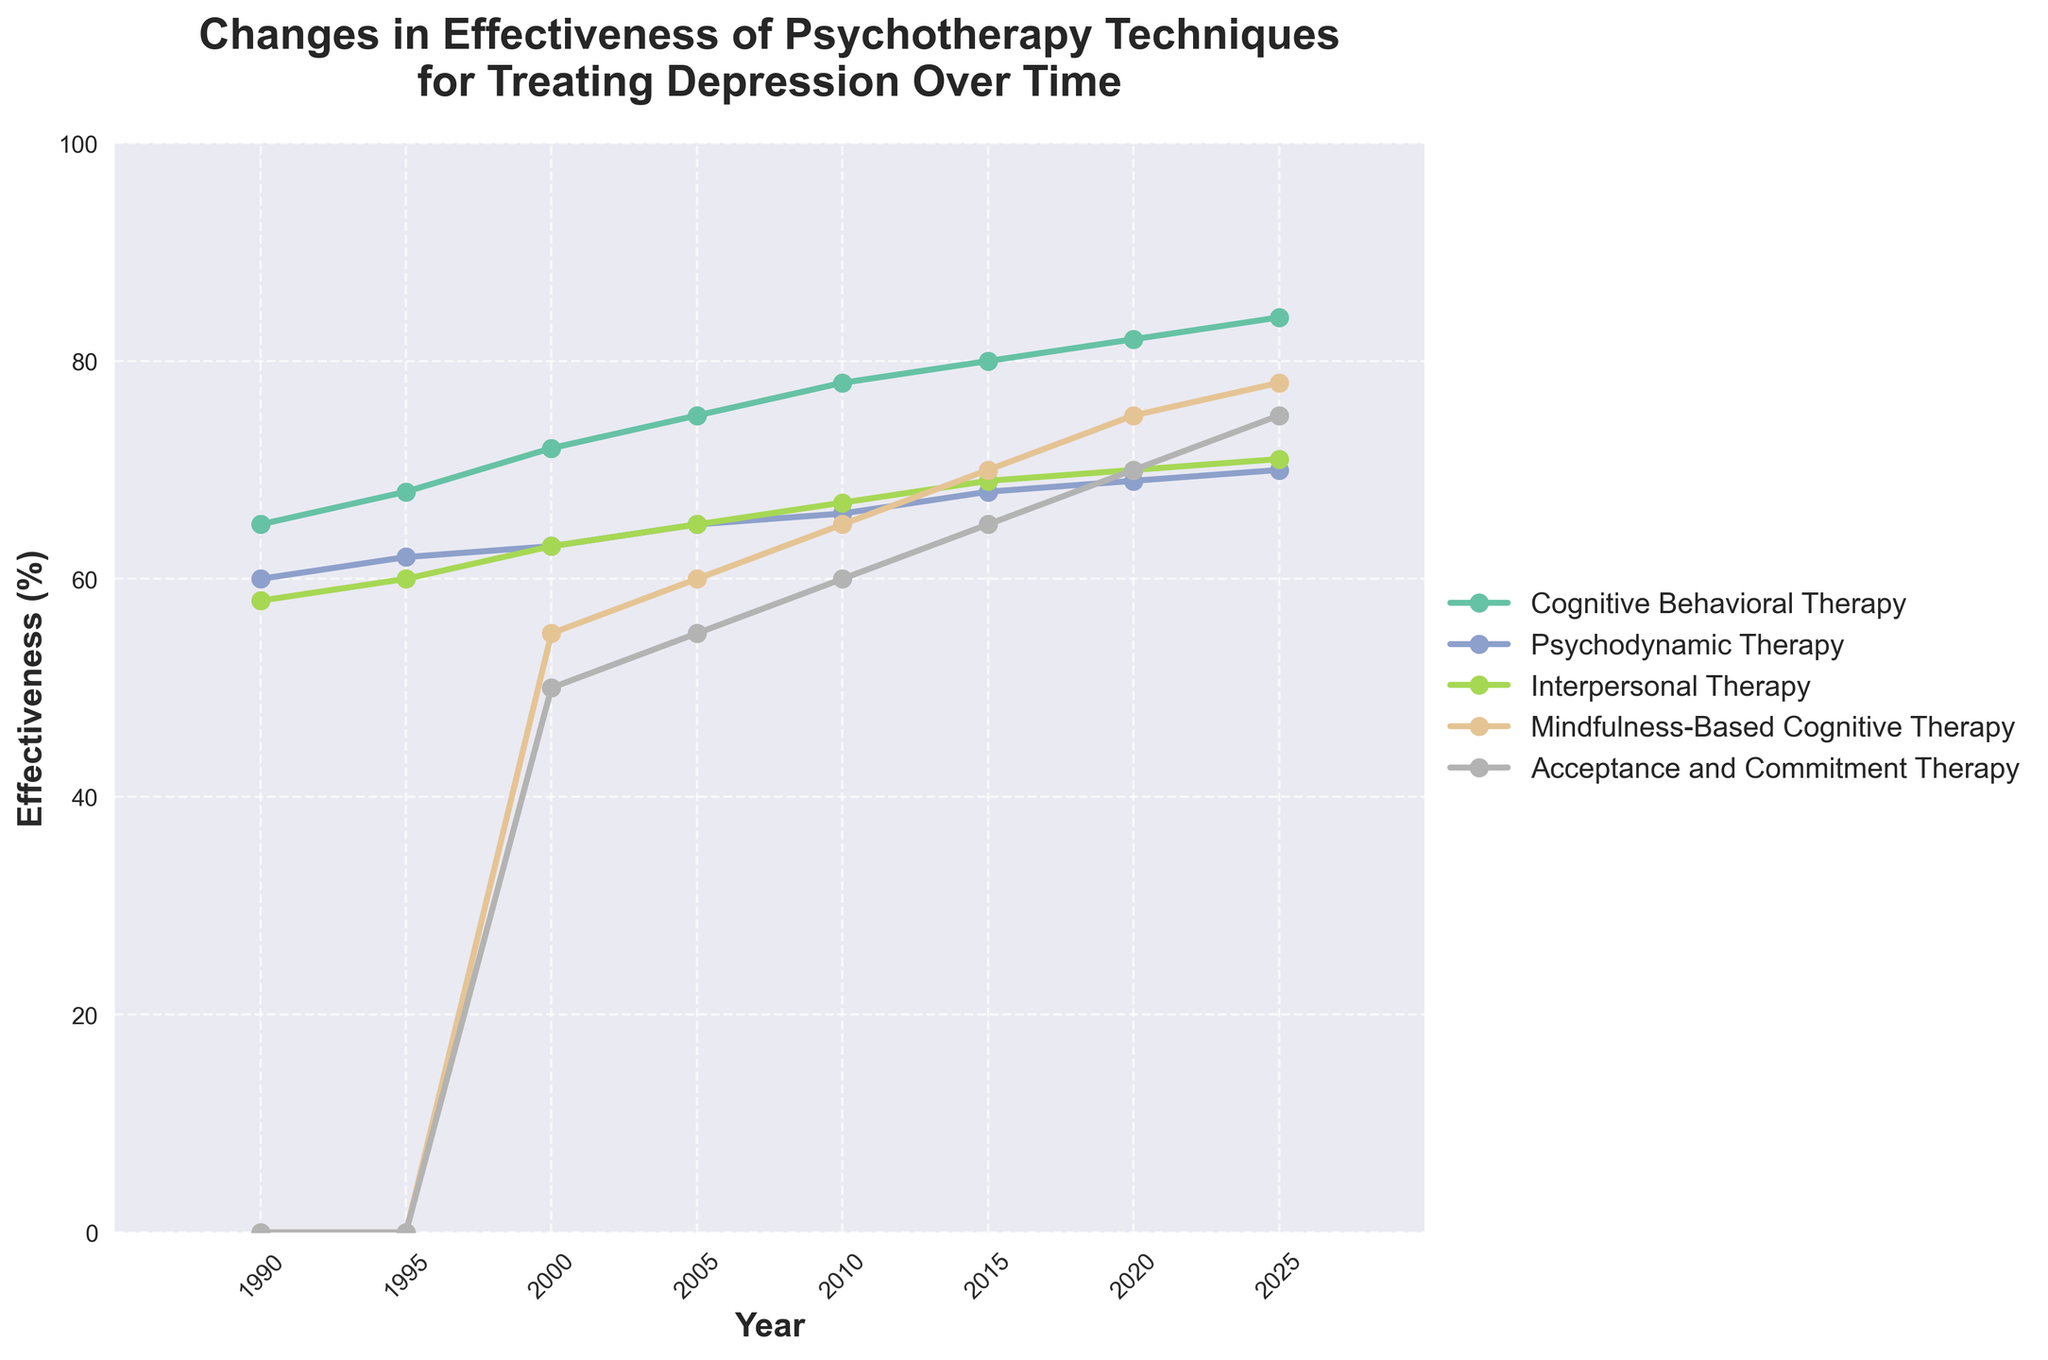What is the trend of Cognitive Behavioral Therapy's effectiveness from 1990 to 2025? To answer this, observe the line representing Cognitive Behavioral Therapy (CBT) on the plot. The line shows a consistent upward trend from 65% in 1990 to 84% in 2025.
Answer: Increasing Which psychotherapy technique had the largest increase in effectiveness between 2000 and 2010? Look at the changes between 2000 and 2010 for each technique. CBT increased by 6% (72% to 78%), Psychodynamic Therapy by 3% (63% to 66%), Interpersonal Therapy by 4% (63% to 67%), Mindfulness-Based Cognitive Therapy by 10% (55% to 65%), and Acceptance and Commitment Therapy by 10% (50% to 60%). Both Mindfulness-Based Cognitive Therapy and Acceptance and Commitment Therapy had the largest increase of 10%.
Answer: Mindfulness-Based Cognitive Therapy and Acceptance and Commitment Therapy Which technique shows the highest effectiveness in 2020? Locate the year 2020 on the x-axis and check the highest value among all techniques. CBT shows the highest effectiveness of 82%.
Answer: Cognitive Behavioral Therapy In which year did Mindfulness-Based Cognitive Therapy achieve a higher effectiveness than Psychodynamic Therapy? Compare the effectiveness of both techniques over time. In 2015, Mindfulness-Based Cognitive Therapy reached 70%, while Psychodynamic Therapy stood at 68%.
Answer: 2015 What is the average effectiveness of Interpersonal Therapy over the years presented in the chart? Sum the effectiveness values for Interpersonal Therapy from 1990 to 2025 and divide by the number of years: (58 + 60 + 63 + 65 + 67 + 69 + 70 + 71)/8 = 523/8 = 65.375.
Answer: 65.375 Between 1990 and 2025, which year displayed the smallest gap in effectiveness between CBT and Psychodynamic Therapy? Compute the differences for each year: 
- 1990: 65 - 60 = 5
- 1995: 68 - 62 = 6
- 2000: 72 - 63 = 9
- 2005: 75 - 65 = 10
- 2010: 78 - 66 = 12
- 2015: 80 - 68 = 12
- 2020: 82 - 69 = 13
- 2025: 84 - 70 = 14
The smallest difference is in 1990.
Answer: 1990 Which psychotherapy techniques had an effectiveness equal to or greater than 70% by the year 2025? Check the effectiveness values in 2025 for all techniques: CBT (84%), Psychodynamic Therapy (70%), Interpersonal Therapy (71%), Mindfulness-Based Cognitive Therapy (78%), and Acceptance and Commitment Therapy (75%). All except Psychodynamic Therapy had effectiveness equal to or greater than 70%.
Answer: Cognitive Behavioral Therapy, Interpersonal Therapy, Mindfulness-Based Cognitive Therapy, Acceptance and Commitment Therapy What is the combined effectiveness of Mindfulness-Based Cognitive Therapy and Acceptance and Commitment Therapy in 2020? Add the effectiveness values for both techniques in 2020: 75% + 70% = 145%.
Answer: 145% Analyze the effectiveness difference between Interpersonal Therapy and Psychodynamic Therapy in 2010 and determine its significance. In 2010, the effectiveness of Interpersonal Therapy was 67%, and Psychodynamic Therapy was 66%. The difference is 67% - 66% = 1%, which is minimal.
Answer: 1% minimal Which psychotherapy technique had the most consistent effectiveness growth over the years? Assess the consistency of the effectiveness increase for each technique by observing the slopes of the lines on the plot. CBT maintains a steady and linear growth pattern from 1990 to 2025.
Answer: Cognitive Behavioral Therapy 